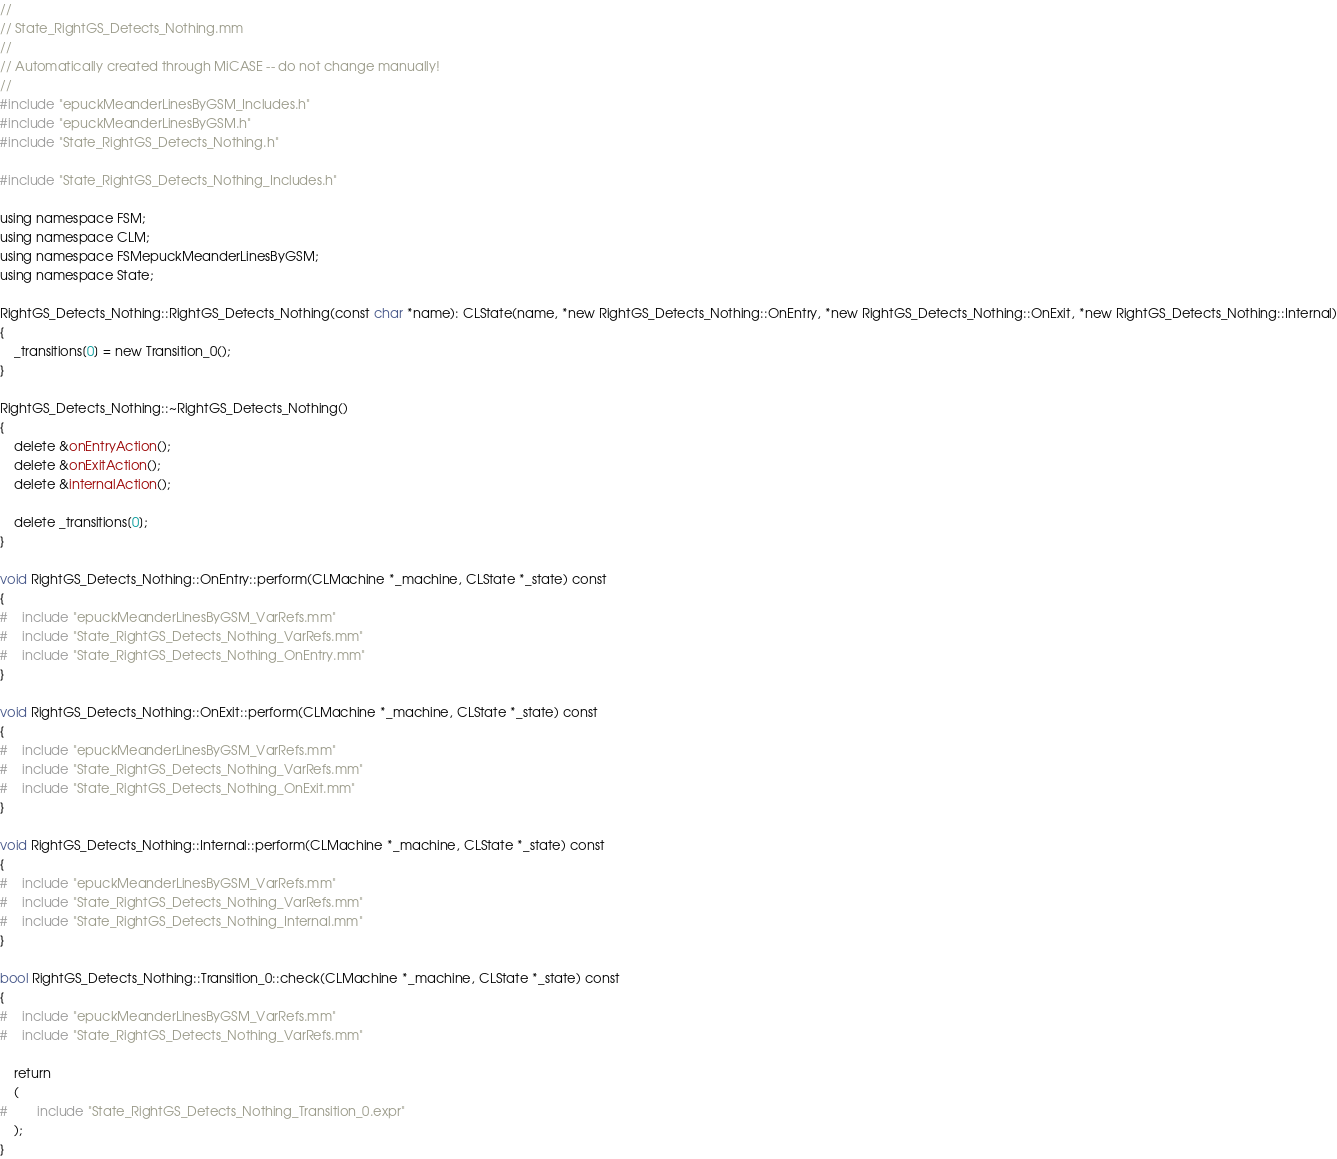Convert code to text. <code><loc_0><loc_0><loc_500><loc_500><_ObjectiveC_>//
// State_RightGS_Detects_Nothing.mm
//
// Automatically created through MiCASE -- do not change manually!
//
#include "epuckMeanderLinesByGSM_Includes.h"
#include "epuckMeanderLinesByGSM.h"
#include "State_RightGS_Detects_Nothing.h"

#include "State_RightGS_Detects_Nothing_Includes.h"

using namespace FSM;
using namespace CLM;
using namespace FSMepuckMeanderLinesByGSM;
using namespace State;

RightGS_Detects_Nothing::RightGS_Detects_Nothing(const char *name): CLState(name, *new RightGS_Detects_Nothing::OnEntry, *new RightGS_Detects_Nothing::OnExit, *new RightGS_Detects_Nothing::Internal)
{
	_transitions[0] = new Transition_0();
}

RightGS_Detects_Nothing::~RightGS_Detects_Nothing()
{
	delete &onEntryAction();
	delete &onExitAction();
	delete &internalAction();

	delete _transitions[0];
}

void RightGS_Detects_Nothing::OnEntry::perform(CLMachine *_machine, CLState *_state) const
{
#	include "epuckMeanderLinesByGSM_VarRefs.mm"
#	include "State_RightGS_Detects_Nothing_VarRefs.mm"
#	include "State_RightGS_Detects_Nothing_OnEntry.mm"
}

void RightGS_Detects_Nothing::OnExit::perform(CLMachine *_machine, CLState *_state) const
{
#	include "epuckMeanderLinesByGSM_VarRefs.mm"
#	include "State_RightGS_Detects_Nothing_VarRefs.mm"
#	include "State_RightGS_Detects_Nothing_OnExit.mm"
}

void RightGS_Detects_Nothing::Internal::perform(CLMachine *_machine, CLState *_state) const
{
#	include "epuckMeanderLinesByGSM_VarRefs.mm"
#	include "State_RightGS_Detects_Nothing_VarRefs.mm"
#	include "State_RightGS_Detects_Nothing_Internal.mm"
}

bool RightGS_Detects_Nothing::Transition_0::check(CLMachine *_machine, CLState *_state) const
{
#	include "epuckMeanderLinesByGSM_VarRefs.mm"
#	include "State_RightGS_Detects_Nothing_VarRefs.mm"

	return
	(
#		include "State_RightGS_Detects_Nothing_Transition_0.expr"
	);
}
</code> 